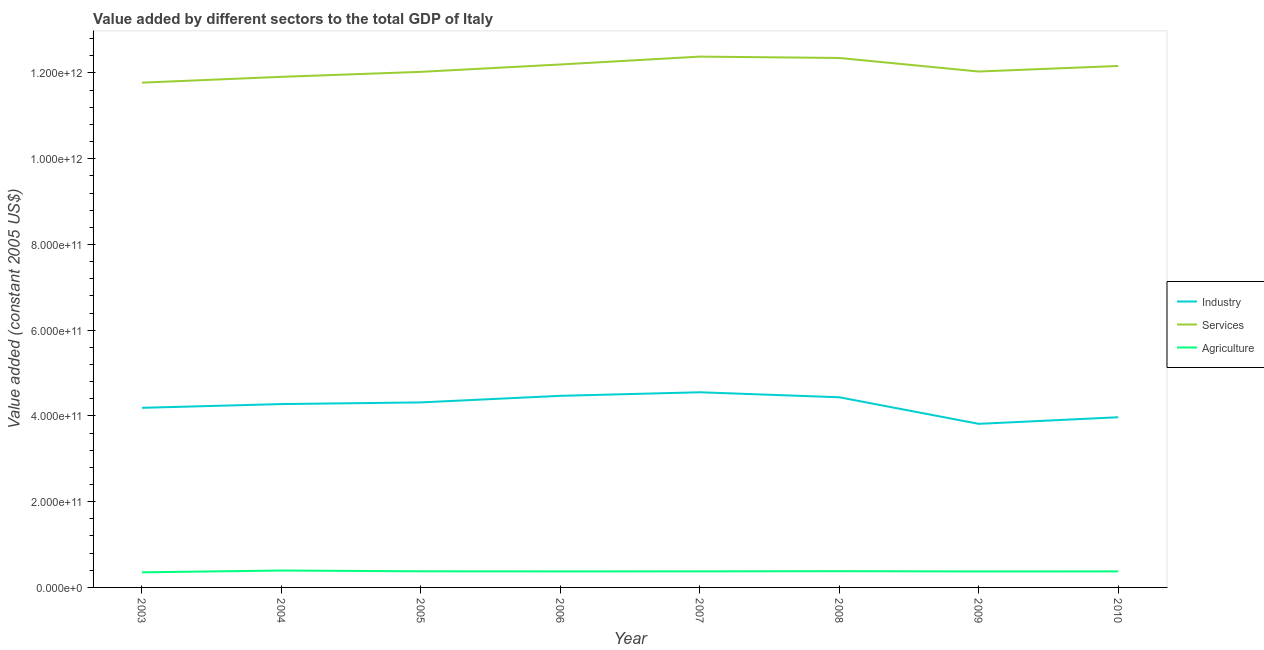What is the value added by industrial sector in 2005?
Provide a short and direct response. 4.32e+11. Across all years, what is the maximum value added by industrial sector?
Make the answer very short. 4.55e+11. Across all years, what is the minimum value added by services?
Offer a terse response. 1.18e+12. What is the total value added by services in the graph?
Your answer should be compact. 9.68e+12. What is the difference between the value added by industrial sector in 2004 and that in 2009?
Offer a terse response. 4.61e+1. What is the difference between the value added by agricultural sector in 2010 and the value added by industrial sector in 2007?
Offer a very short reply. -4.18e+11. What is the average value added by industrial sector per year?
Make the answer very short. 4.25e+11. In the year 2008, what is the difference between the value added by services and value added by industrial sector?
Provide a short and direct response. 7.91e+11. In how many years, is the value added by industrial sector greater than 40000000000 US$?
Offer a very short reply. 8. What is the ratio of the value added by services in 2003 to that in 2010?
Provide a short and direct response. 0.97. Is the value added by services in 2005 less than that in 2009?
Your answer should be compact. Yes. Is the difference between the value added by agricultural sector in 2004 and 2010 greater than the difference between the value added by industrial sector in 2004 and 2010?
Your response must be concise. No. What is the difference between the highest and the second highest value added by industrial sector?
Your answer should be very brief. 8.29e+09. What is the difference between the highest and the lowest value added by industrial sector?
Offer a very short reply. 7.36e+1. Is the value added by industrial sector strictly less than the value added by services over the years?
Provide a short and direct response. Yes. How many years are there in the graph?
Provide a short and direct response. 8. What is the difference between two consecutive major ticks on the Y-axis?
Give a very brief answer. 2.00e+11. Are the values on the major ticks of Y-axis written in scientific E-notation?
Offer a very short reply. Yes. Does the graph contain any zero values?
Your answer should be compact. No. How many legend labels are there?
Make the answer very short. 3. How are the legend labels stacked?
Your response must be concise. Vertical. What is the title of the graph?
Your response must be concise. Value added by different sectors to the total GDP of Italy. Does "Labor Tax" appear as one of the legend labels in the graph?
Keep it short and to the point. No. What is the label or title of the Y-axis?
Keep it short and to the point. Value added (constant 2005 US$). What is the Value added (constant 2005 US$) of Industry in 2003?
Give a very brief answer. 4.19e+11. What is the Value added (constant 2005 US$) of Services in 2003?
Your answer should be compact. 1.18e+12. What is the Value added (constant 2005 US$) of Agriculture in 2003?
Make the answer very short. 3.52e+1. What is the Value added (constant 2005 US$) of Industry in 2004?
Offer a terse response. 4.28e+11. What is the Value added (constant 2005 US$) in Services in 2004?
Your answer should be very brief. 1.19e+12. What is the Value added (constant 2005 US$) in Agriculture in 2004?
Provide a short and direct response. 3.94e+1. What is the Value added (constant 2005 US$) of Industry in 2005?
Offer a very short reply. 4.32e+11. What is the Value added (constant 2005 US$) of Services in 2005?
Provide a short and direct response. 1.20e+12. What is the Value added (constant 2005 US$) of Agriculture in 2005?
Give a very brief answer. 3.76e+1. What is the Value added (constant 2005 US$) in Industry in 2006?
Your answer should be compact. 4.47e+11. What is the Value added (constant 2005 US$) of Services in 2006?
Your answer should be very brief. 1.22e+12. What is the Value added (constant 2005 US$) in Agriculture in 2006?
Make the answer very short. 3.74e+1. What is the Value added (constant 2005 US$) of Industry in 2007?
Provide a short and direct response. 4.55e+11. What is the Value added (constant 2005 US$) in Services in 2007?
Offer a terse response. 1.24e+12. What is the Value added (constant 2005 US$) of Agriculture in 2007?
Your answer should be compact. 3.74e+1. What is the Value added (constant 2005 US$) in Industry in 2008?
Keep it short and to the point. 4.44e+11. What is the Value added (constant 2005 US$) of Services in 2008?
Offer a very short reply. 1.24e+12. What is the Value added (constant 2005 US$) of Agriculture in 2008?
Your answer should be compact. 3.79e+1. What is the Value added (constant 2005 US$) in Industry in 2009?
Ensure brevity in your answer.  3.82e+11. What is the Value added (constant 2005 US$) of Services in 2009?
Make the answer very short. 1.20e+12. What is the Value added (constant 2005 US$) in Agriculture in 2009?
Provide a succinct answer. 3.72e+1. What is the Value added (constant 2005 US$) of Industry in 2010?
Your answer should be compact. 3.97e+11. What is the Value added (constant 2005 US$) of Services in 2010?
Offer a terse response. 1.22e+12. What is the Value added (constant 2005 US$) in Agriculture in 2010?
Your answer should be very brief. 3.74e+1. Across all years, what is the maximum Value added (constant 2005 US$) of Industry?
Keep it short and to the point. 4.55e+11. Across all years, what is the maximum Value added (constant 2005 US$) in Services?
Your response must be concise. 1.24e+12. Across all years, what is the maximum Value added (constant 2005 US$) of Agriculture?
Your response must be concise. 3.94e+1. Across all years, what is the minimum Value added (constant 2005 US$) in Industry?
Your answer should be compact. 3.82e+11. Across all years, what is the minimum Value added (constant 2005 US$) in Services?
Keep it short and to the point. 1.18e+12. Across all years, what is the minimum Value added (constant 2005 US$) in Agriculture?
Give a very brief answer. 3.52e+1. What is the total Value added (constant 2005 US$) of Industry in the graph?
Keep it short and to the point. 3.40e+12. What is the total Value added (constant 2005 US$) of Services in the graph?
Provide a short and direct response. 9.68e+12. What is the total Value added (constant 2005 US$) in Agriculture in the graph?
Your answer should be very brief. 3.00e+11. What is the difference between the Value added (constant 2005 US$) of Industry in 2003 and that in 2004?
Your answer should be compact. -8.75e+09. What is the difference between the Value added (constant 2005 US$) of Services in 2003 and that in 2004?
Make the answer very short. -1.36e+1. What is the difference between the Value added (constant 2005 US$) in Agriculture in 2003 and that in 2004?
Make the answer very short. -4.22e+09. What is the difference between the Value added (constant 2005 US$) in Industry in 2003 and that in 2005?
Ensure brevity in your answer.  -1.27e+1. What is the difference between the Value added (constant 2005 US$) in Services in 2003 and that in 2005?
Offer a terse response. -2.52e+1. What is the difference between the Value added (constant 2005 US$) in Agriculture in 2003 and that in 2005?
Keep it short and to the point. -2.38e+09. What is the difference between the Value added (constant 2005 US$) of Industry in 2003 and that in 2006?
Provide a succinct answer. -2.80e+1. What is the difference between the Value added (constant 2005 US$) of Services in 2003 and that in 2006?
Keep it short and to the point. -4.24e+1. What is the difference between the Value added (constant 2005 US$) of Agriculture in 2003 and that in 2006?
Offer a terse response. -2.15e+09. What is the difference between the Value added (constant 2005 US$) of Industry in 2003 and that in 2007?
Your answer should be very brief. -3.63e+1. What is the difference between the Value added (constant 2005 US$) of Services in 2003 and that in 2007?
Your response must be concise. -6.07e+1. What is the difference between the Value added (constant 2005 US$) in Agriculture in 2003 and that in 2007?
Give a very brief answer. -2.22e+09. What is the difference between the Value added (constant 2005 US$) of Industry in 2003 and that in 2008?
Provide a short and direct response. -2.46e+1. What is the difference between the Value added (constant 2005 US$) of Services in 2003 and that in 2008?
Provide a short and direct response. -5.76e+1. What is the difference between the Value added (constant 2005 US$) of Agriculture in 2003 and that in 2008?
Your answer should be very brief. -2.65e+09. What is the difference between the Value added (constant 2005 US$) of Industry in 2003 and that in 2009?
Provide a short and direct response. 3.74e+1. What is the difference between the Value added (constant 2005 US$) of Services in 2003 and that in 2009?
Offer a very short reply. -2.60e+1. What is the difference between the Value added (constant 2005 US$) in Agriculture in 2003 and that in 2009?
Ensure brevity in your answer.  -2.03e+09. What is the difference between the Value added (constant 2005 US$) of Industry in 2003 and that in 2010?
Make the answer very short. 2.20e+1. What is the difference between the Value added (constant 2005 US$) in Services in 2003 and that in 2010?
Offer a terse response. -3.89e+1. What is the difference between the Value added (constant 2005 US$) of Agriculture in 2003 and that in 2010?
Keep it short and to the point. -2.17e+09. What is the difference between the Value added (constant 2005 US$) in Industry in 2004 and that in 2005?
Offer a very short reply. -3.91e+09. What is the difference between the Value added (constant 2005 US$) in Services in 2004 and that in 2005?
Your answer should be compact. -1.16e+1. What is the difference between the Value added (constant 2005 US$) in Agriculture in 2004 and that in 2005?
Provide a short and direct response. 1.84e+09. What is the difference between the Value added (constant 2005 US$) in Industry in 2004 and that in 2006?
Ensure brevity in your answer.  -1.92e+1. What is the difference between the Value added (constant 2005 US$) in Services in 2004 and that in 2006?
Make the answer very short. -2.88e+1. What is the difference between the Value added (constant 2005 US$) of Agriculture in 2004 and that in 2006?
Keep it short and to the point. 2.06e+09. What is the difference between the Value added (constant 2005 US$) in Industry in 2004 and that in 2007?
Provide a succinct answer. -2.75e+1. What is the difference between the Value added (constant 2005 US$) in Services in 2004 and that in 2007?
Offer a terse response. -4.71e+1. What is the difference between the Value added (constant 2005 US$) of Agriculture in 2004 and that in 2007?
Provide a succinct answer. 2.00e+09. What is the difference between the Value added (constant 2005 US$) of Industry in 2004 and that in 2008?
Your answer should be compact. -1.59e+1. What is the difference between the Value added (constant 2005 US$) in Services in 2004 and that in 2008?
Offer a very short reply. -4.40e+1. What is the difference between the Value added (constant 2005 US$) of Agriculture in 2004 and that in 2008?
Provide a short and direct response. 1.57e+09. What is the difference between the Value added (constant 2005 US$) in Industry in 2004 and that in 2009?
Provide a succinct answer. 4.61e+1. What is the difference between the Value added (constant 2005 US$) in Services in 2004 and that in 2009?
Your answer should be compact. -1.24e+1. What is the difference between the Value added (constant 2005 US$) of Agriculture in 2004 and that in 2009?
Ensure brevity in your answer.  2.18e+09. What is the difference between the Value added (constant 2005 US$) in Industry in 2004 and that in 2010?
Your answer should be compact. 3.07e+1. What is the difference between the Value added (constant 2005 US$) of Services in 2004 and that in 2010?
Offer a very short reply. -2.53e+1. What is the difference between the Value added (constant 2005 US$) in Agriculture in 2004 and that in 2010?
Your answer should be compact. 2.05e+09. What is the difference between the Value added (constant 2005 US$) in Industry in 2005 and that in 2006?
Ensure brevity in your answer.  -1.53e+1. What is the difference between the Value added (constant 2005 US$) in Services in 2005 and that in 2006?
Your answer should be compact. -1.72e+1. What is the difference between the Value added (constant 2005 US$) in Agriculture in 2005 and that in 2006?
Your response must be concise. 2.22e+08. What is the difference between the Value added (constant 2005 US$) in Industry in 2005 and that in 2007?
Your answer should be very brief. -2.36e+1. What is the difference between the Value added (constant 2005 US$) of Services in 2005 and that in 2007?
Your answer should be compact. -3.55e+1. What is the difference between the Value added (constant 2005 US$) of Agriculture in 2005 and that in 2007?
Provide a short and direct response. 1.60e+08. What is the difference between the Value added (constant 2005 US$) of Industry in 2005 and that in 2008?
Provide a succinct answer. -1.20e+1. What is the difference between the Value added (constant 2005 US$) of Services in 2005 and that in 2008?
Your answer should be very brief. -3.24e+1. What is the difference between the Value added (constant 2005 US$) in Agriculture in 2005 and that in 2008?
Ensure brevity in your answer.  -2.73e+08. What is the difference between the Value added (constant 2005 US$) in Industry in 2005 and that in 2009?
Keep it short and to the point. 5.00e+1. What is the difference between the Value added (constant 2005 US$) of Services in 2005 and that in 2009?
Your response must be concise. -7.75e+08. What is the difference between the Value added (constant 2005 US$) in Agriculture in 2005 and that in 2009?
Keep it short and to the point. 3.42e+08. What is the difference between the Value added (constant 2005 US$) of Industry in 2005 and that in 2010?
Offer a terse response. 3.46e+1. What is the difference between the Value added (constant 2005 US$) in Services in 2005 and that in 2010?
Your answer should be very brief. -1.37e+1. What is the difference between the Value added (constant 2005 US$) in Agriculture in 2005 and that in 2010?
Offer a terse response. 2.07e+08. What is the difference between the Value added (constant 2005 US$) of Industry in 2006 and that in 2007?
Your answer should be very brief. -8.29e+09. What is the difference between the Value added (constant 2005 US$) in Services in 2006 and that in 2007?
Give a very brief answer. -1.84e+1. What is the difference between the Value added (constant 2005 US$) of Agriculture in 2006 and that in 2007?
Provide a succinct answer. -6.16e+07. What is the difference between the Value added (constant 2005 US$) in Industry in 2006 and that in 2008?
Provide a succinct answer. 3.36e+09. What is the difference between the Value added (constant 2005 US$) in Services in 2006 and that in 2008?
Provide a short and direct response. -1.52e+1. What is the difference between the Value added (constant 2005 US$) of Agriculture in 2006 and that in 2008?
Your answer should be compact. -4.95e+08. What is the difference between the Value added (constant 2005 US$) in Industry in 2006 and that in 2009?
Make the answer very short. 6.54e+1. What is the difference between the Value added (constant 2005 US$) in Services in 2006 and that in 2009?
Offer a very short reply. 1.64e+1. What is the difference between the Value added (constant 2005 US$) in Agriculture in 2006 and that in 2009?
Your answer should be compact. 1.21e+08. What is the difference between the Value added (constant 2005 US$) of Industry in 2006 and that in 2010?
Your answer should be compact. 5.00e+1. What is the difference between the Value added (constant 2005 US$) of Services in 2006 and that in 2010?
Keep it short and to the point. 3.45e+09. What is the difference between the Value added (constant 2005 US$) in Agriculture in 2006 and that in 2010?
Your answer should be compact. -1.46e+07. What is the difference between the Value added (constant 2005 US$) of Industry in 2007 and that in 2008?
Your response must be concise. 1.17e+1. What is the difference between the Value added (constant 2005 US$) of Services in 2007 and that in 2008?
Your answer should be compact. 3.16e+09. What is the difference between the Value added (constant 2005 US$) of Agriculture in 2007 and that in 2008?
Make the answer very short. -4.34e+08. What is the difference between the Value added (constant 2005 US$) in Industry in 2007 and that in 2009?
Provide a succinct answer. 7.36e+1. What is the difference between the Value added (constant 2005 US$) in Services in 2007 and that in 2009?
Keep it short and to the point. 3.48e+1. What is the difference between the Value added (constant 2005 US$) in Agriculture in 2007 and that in 2009?
Your answer should be compact. 1.82e+08. What is the difference between the Value added (constant 2005 US$) of Industry in 2007 and that in 2010?
Offer a terse response. 5.83e+1. What is the difference between the Value added (constant 2005 US$) in Services in 2007 and that in 2010?
Your response must be concise. 2.18e+1. What is the difference between the Value added (constant 2005 US$) of Agriculture in 2007 and that in 2010?
Your response must be concise. 4.69e+07. What is the difference between the Value added (constant 2005 US$) of Industry in 2008 and that in 2009?
Keep it short and to the point. 6.20e+1. What is the difference between the Value added (constant 2005 US$) of Services in 2008 and that in 2009?
Offer a terse response. 3.16e+1. What is the difference between the Value added (constant 2005 US$) of Agriculture in 2008 and that in 2009?
Keep it short and to the point. 6.16e+08. What is the difference between the Value added (constant 2005 US$) in Industry in 2008 and that in 2010?
Offer a terse response. 4.66e+1. What is the difference between the Value added (constant 2005 US$) in Services in 2008 and that in 2010?
Give a very brief answer. 1.87e+1. What is the difference between the Value added (constant 2005 US$) in Agriculture in 2008 and that in 2010?
Provide a succinct answer. 4.81e+08. What is the difference between the Value added (constant 2005 US$) in Industry in 2009 and that in 2010?
Your response must be concise. -1.54e+1. What is the difference between the Value added (constant 2005 US$) of Services in 2009 and that in 2010?
Your answer should be very brief. -1.30e+1. What is the difference between the Value added (constant 2005 US$) in Agriculture in 2009 and that in 2010?
Provide a short and direct response. -1.35e+08. What is the difference between the Value added (constant 2005 US$) in Industry in 2003 and the Value added (constant 2005 US$) in Services in 2004?
Your response must be concise. -7.72e+11. What is the difference between the Value added (constant 2005 US$) in Industry in 2003 and the Value added (constant 2005 US$) in Agriculture in 2004?
Your answer should be compact. 3.80e+11. What is the difference between the Value added (constant 2005 US$) in Services in 2003 and the Value added (constant 2005 US$) in Agriculture in 2004?
Your response must be concise. 1.14e+12. What is the difference between the Value added (constant 2005 US$) in Industry in 2003 and the Value added (constant 2005 US$) in Services in 2005?
Offer a terse response. -7.84e+11. What is the difference between the Value added (constant 2005 US$) of Industry in 2003 and the Value added (constant 2005 US$) of Agriculture in 2005?
Make the answer very short. 3.81e+11. What is the difference between the Value added (constant 2005 US$) in Services in 2003 and the Value added (constant 2005 US$) in Agriculture in 2005?
Your answer should be very brief. 1.14e+12. What is the difference between the Value added (constant 2005 US$) in Industry in 2003 and the Value added (constant 2005 US$) in Services in 2006?
Your answer should be compact. -8.01e+11. What is the difference between the Value added (constant 2005 US$) of Industry in 2003 and the Value added (constant 2005 US$) of Agriculture in 2006?
Offer a very short reply. 3.82e+11. What is the difference between the Value added (constant 2005 US$) of Services in 2003 and the Value added (constant 2005 US$) of Agriculture in 2006?
Give a very brief answer. 1.14e+12. What is the difference between the Value added (constant 2005 US$) in Industry in 2003 and the Value added (constant 2005 US$) in Services in 2007?
Offer a very short reply. -8.19e+11. What is the difference between the Value added (constant 2005 US$) of Industry in 2003 and the Value added (constant 2005 US$) of Agriculture in 2007?
Offer a very short reply. 3.82e+11. What is the difference between the Value added (constant 2005 US$) of Services in 2003 and the Value added (constant 2005 US$) of Agriculture in 2007?
Keep it short and to the point. 1.14e+12. What is the difference between the Value added (constant 2005 US$) in Industry in 2003 and the Value added (constant 2005 US$) in Services in 2008?
Provide a short and direct response. -8.16e+11. What is the difference between the Value added (constant 2005 US$) of Industry in 2003 and the Value added (constant 2005 US$) of Agriculture in 2008?
Make the answer very short. 3.81e+11. What is the difference between the Value added (constant 2005 US$) in Services in 2003 and the Value added (constant 2005 US$) in Agriculture in 2008?
Give a very brief answer. 1.14e+12. What is the difference between the Value added (constant 2005 US$) of Industry in 2003 and the Value added (constant 2005 US$) of Services in 2009?
Give a very brief answer. -7.84e+11. What is the difference between the Value added (constant 2005 US$) in Industry in 2003 and the Value added (constant 2005 US$) in Agriculture in 2009?
Give a very brief answer. 3.82e+11. What is the difference between the Value added (constant 2005 US$) of Services in 2003 and the Value added (constant 2005 US$) of Agriculture in 2009?
Provide a succinct answer. 1.14e+12. What is the difference between the Value added (constant 2005 US$) in Industry in 2003 and the Value added (constant 2005 US$) in Services in 2010?
Offer a very short reply. -7.97e+11. What is the difference between the Value added (constant 2005 US$) in Industry in 2003 and the Value added (constant 2005 US$) in Agriculture in 2010?
Provide a short and direct response. 3.82e+11. What is the difference between the Value added (constant 2005 US$) of Services in 2003 and the Value added (constant 2005 US$) of Agriculture in 2010?
Offer a very short reply. 1.14e+12. What is the difference between the Value added (constant 2005 US$) in Industry in 2004 and the Value added (constant 2005 US$) in Services in 2005?
Offer a very short reply. -7.75e+11. What is the difference between the Value added (constant 2005 US$) in Industry in 2004 and the Value added (constant 2005 US$) in Agriculture in 2005?
Keep it short and to the point. 3.90e+11. What is the difference between the Value added (constant 2005 US$) of Services in 2004 and the Value added (constant 2005 US$) of Agriculture in 2005?
Offer a terse response. 1.15e+12. What is the difference between the Value added (constant 2005 US$) in Industry in 2004 and the Value added (constant 2005 US$) in Services in 2006?
Give a very brief answer. -7.92e+11. What is the difference between the Value added (constant 2005 US$) of Industry in 2004 and the Value added (constant 2005 US$) of Agriculture in 2006?
Provide a short and direct response. 3.90e+11. What is the difference between the Value added (constant 2005 US$) of Services in 2004 and the Value added (constant 2005 US$) of Agriculture in 2006?
Your response must be concise. 1.15e+12. What is the difference between the Value added (constant 2005 US$) in Industry in 2004 and the Value added (constant 2005 US$) in Services in 2007?
Give a very brief answer. -8.10e+11. What is the difference between the Value added (constant 2005 US$) of Industry in 2004 and the Value added (constant 2005 US$) of Agriculture in 2007?
Give a very brief answer. 3.90e+11. What is the difference between the Value added (constant 2005 US$) of Services in 2004 and the Value added (constant 2005 US$) of Agriculture in 2007?
Your answer should be very brief. 1.15e+12. What is the difference between the Value added (constant 2005 US$) in Industry in 2004 and the Value added (constant 2005 US$) in Services in 2008?
Provide a succinct answer. -8.07e+11. What is the difference between the Value added (constant 2005 US$) in Industry in 2004 and the Value added (constant 2005 US$) in Agriculture in 2008?
Provide a succinct answer. 3.90e+11. What is the difference between the Value added (constant 2005 US$) in Services in 2004 and the Value added (constant 2005 US$) in Agriculture in 2008?
Offer a terse response. 1.15e+12. What is the difference between the Value added (constant 2005 US$) in Industry in 2004 and the Value added (constant 2005 US$) in Services in 2009?
Your response must be concise. -7.76e+11. What is the difference between the Value added (constant 2005 US$) in Industry in 2004 and the Value added (constant 2005 US$) in Agriculture in 2009?
Provide a succinct answer. 3.90e+11. What is the difference between the Value added (constant 2005 US$) of Services in 2004 and the Value added (constant 2005 US$) of Agriculture in 2009?
Keep it short and to the point. 1.15e+12. What is the difference between the Value added (constant 2005 US$) of Industry in 2004 and the Value added (constant 2005 US$) of Services in 2010?
Ensure brevity in your answer.  -7.89e+11. What is the difference between the Value added (constant 2005 US$) of Industry in 2004 and the Value added (constant 2005 US$) of Agriculture in 2010?
Offer a terse response. 3.90e+11. What is the difference between the Value added (constant 2005 US$) in Services in 2004 and the Value added (constant 2005 US$) in Agriculture in 2010?
Provide a short and direct response. 1.15e+12. What is the difference between the Value added (constant 2005 US$) in Industry in 2005 and the Value added (constant 2005 US$) in Services in 2006?
Make the answer very short. -7.88e+11. What is the difference between the Value added (constant 2005 US$) in Industry in 2005 and the Value added (constant 2005 US$) in Agriculture in 2006?
Keep it short and to the point. 3.94e+11. What is the difference between the Value added (constant 2005 US$) of Services in 2005 and the Value added (constant 2005 US$) of Agriculture in 2006?
Provide a succinct answer. 1.17e+12. What is the difference between the Value added (constant 2005 US$) of Industry in 2005 and the Value added (constant 2005 US$) of Services in 2007?
Provide a short and direct response. -8.07e+11. What is the difference between the Value added (constant 2005 US$) in Industry in 2005 and the Value added (constant 2005 US$) in Agriculture in 2007?
Your response must be concise. 3.94e+11. What is the difference between the Value added (constant 2005 US$) of Services in 2005 and the Value added (constant 2005 US$) of Agriculture in 2007?
Your response must be concise. 1.17e+12. What is the difference between the Value added (constant 2005 US$) of Industry in 2005 and the Value added (constant 2005 US$) of Services in 2008?
Provide a short and direct response. -8.03e+11. What is the difference between the Value added (constant 2005 US$) of Industry in 2005 and the Value added (constant 2005 US$) of Agriculture in 2008?
Keep it short and to the point. 3.94e+11. What is the difference between the Value added (constant 2005 US$) in Services in 2005 and the Value added (constant 2005 US$) in Agriculture in 2008?
Your response must be concise. 1.16e+12. What is the difference between the Value added (constant 2005 US$) of Industry in 2005 and the Value added (constant 2005 US$) of Services in 2009?
Offer a very short reply. -7.72e+11. What is the difference between the Value added (constant 2005 US$) of Industry in 2005 and the Value added (constant 2005 US$) of Agriculture in 2009?
Ensure brevity in your answer.  3.94e+11. What is the difference between the Value added (constant 2005 US$) in Services in 2005 and the Value added (constant 2005 US$) in Agriculture in 2009?
Offer a very short reply. 1.17e+12. What is the difference between the Value added (constant 2005 US$) of Industry in 2005 and the Value added (constant 2005 US$) of Services in 2010?
Make the answer very short. -7.85e+11. What is the difference between the Value added (constant 2005 US$) of Industry in 2005 and the Value added (constant 2005 US$) of Agriculture in 2010?
Ensure brevity in your answer.  3.94e+11. What is the difference between the Value added (constant 2005 US$) in Services in 2005 and the Value added (constant 2005 US$) in Agriculture in 2010?
Offer a terse response. 1.17e+12. What is the difference between the Value added (constant 2005 US$) of Industry in 2006 and the Value added (constant 2005 US$) of Services in 2007?
Your response must be concise. -7.91e+11. What is the difference between the Value added (constant 2005 US$) in Industry in 2006 and the Value added (constant 2005 US$) in Agriculture in 2007?
Ensure brevity in your answer.  4.09e+11. What is the difference between the Value added (constant 2005 US$) of Services in 2006 and the Value added (constant 2005 US$) of Agriculture in 2007?
Make the answer very short. 1.18e+12. What is the difference between the Value added (constant 2005 US$) in Industry in 2006 and the Value added (constant 2005 US$) in Services in 2008?
Give a very brief answer. -7.88e+11. What is the difference between the Value added (constant 2005 US$) in Industry in 2006 and the Value added (constant 2005 US$) in Agriculture in 2008?
Make the answer very short. 4.09e+11. What is the difference between the Value added (constant 2005 US$) in Services in 2006 and the Value added (constant 2005 US$) in Agriculture in 2008?
Your answer should be compact. 1.18e+12. What is the difference between the Value added (constant 2005 US$) of Industry in 2006 and the Value added (constant 2005 US$) of Services in 2009?
Your response must be concise. -7.56e+11. What is the difference between the Value added (constant 2005 US$) in Industry in 2006 and the Value added (constant 2005 US$) in Agriculture in 2009?
Provide a succinct answer. 4.10e+11. What is the difference between the Value added (constant 2005 US$) in Services in 2006 and the Value added (constant 2005 US$) in Agriculture in 2009?
Keep it short and to the point. 1.18e+12. What is the difference between the Value added (constant 2005 US$) in Industry in 2006 and the Value added (constant 2005 US$) in Services in 2010?
Your answer should be compact. -7.69e+11. What is the difference between the Value added (constant 2005 US$) in Industry in 2006 and the Value added (constant 2005 US$) in Agriculture in 2010?
Your answer should be compact. 4.10e+11. What is the difference between the Value added (constant 2005 US$) in Services in 2006 and the Value added (constant 2005 US$) in Agriculture in 2010?
Offer a very short reply. 1.18e+12. What is the difference between the Value added (constant 2005 US$) of Industry in 2007 and the Value added (constant 2005 US$) of Services in 2008?
Give a very brief answer. -7.80e+11. What is the difference between the Value added (constant 2005 US$) in Industry in 2007 and the Value added (constant 2005 US$) in Agriculture in 2008?
Make the answer very short. 4.17e+11. What is the difference between the Value added (constant 2005 US$) in Services in 2007 and the Value added (constant 2005 US$) in Agriculture in 2008?
Your answer should be compact. 1.20e+12. What is the difference between the Value added (constant 2005 US$) in Industry in 2007 and the Value added (constant 2005 US$) in Services in 2009?
Your answer should be compact. -7.48e+11. What is the difference between the Value added (constant 2005 US$) of Industry in 2007 and the Value added (constant 2005 US$) of Agriculture in 2009?
Your answer should be compact. 4.18e+11. What is the difference between the Value added (constant 2005 US$) of Services in 2007 and the Value added (constant 2005 US$) of Agriculture in 2009?
Keep it short and to the point. 1.20e+12. What is the difference between the Value added (constant 2005 US$) in Industry in 2007 and the Value added (constant 2005 US$) in Services in 2010?
Your answer should be very brief. -7.61e+11. What is the difference between the Value added (constant 2005 US$) in Industry in 2007 and the Value added (constant 2005 US$) in Agriculture in 2010?
Offer a terse response. 4.18e+11. What is the difference between the Value added (constant 2005 US$) of Services in 2007 and the Value added (constant 2005 US$) of Agriculture in 2010?
Make the answer very short. 1.20e+12. What is the difference between the Value added (constant 2005 US$) of Industry in 2008 and the Value added (constant 2005 US$) of Services in 2009?
Ensure brevity in your answer.  -7.60e+11. What is the difference between the Value added (constant 2005 US$) of Industry in 2008 and the Value added (constant 2005 US$) of Agriculture in 2009?
Your answer should be compact. 4.06e+11. What is the difference between the Value added (constant 2005 US$) in Services in 2008 and the Value added (constant 2005 US$) in Agriculture in 2009?
Provide a short and direct response. 1.20e+12. What is the difference between the Value added (constant 2005 US$) of Industry in 2008 and the Value added (constant 2005 US$) of Services in 2010?
Provide a succinct answer. -7.73e+11. What is the difference between the Value added (constant 2005 US$) in Industry in 2008 and the Value added (constant 2005 US$) in Agriculture in 2010?
Provide a succinct answer. 4.06e+11. What is the difference between the Value added (constant 2005 US$) of Services in 2008 and the Value added (constant 2005 US$) of Agriculture in 2010?
Your response must be concise. 1.20e+12. What is the difference between the Value added (constant 2005 US$) of Industry in 2009 and the Value added (constant 2005 US$) of Services in 2010?
Your response must be concise. -8.35e+11. What is the difference between the Value added (constant 2005 US$) in Industry in 2009 and the Value added (constant 2005 US$) in Agriculture in 2010?
Keep it short and to the point. 3.44e+11. What is the difference between the Value added (constant 2005 US$) of Services in 2009 and the Value added (constant 2005 US$) of Agriculture in 2010?
Keep it short and to the point. 1.17e+12. What is the average Value added (constant 2005 US$) of Industry per year?
Your answer should be very brief. 4.25e+11. What is the average Value added (constant 2005 US$) in Services per year?
Your answer should be very brief. 1.21e+12. What is the average Value added (constant 2005 US$) in Agriculture per year?
Keep it short and to the point. 3.74e+1. In the year 2003, what is the difference between the Value added (constant 2005 US$) of Industry and Value added (constant 2005 US$) of Services?
Keep it short and to the point. -7.59e+11. In the year 2003, what is the difference between the Value added (constant 2005 US$) of Industry and Value added (constant 2005 US$) of Agriculture?
Offer a very short reply. 3.84e+11. In the year 2003, what is the difference between the Value added (constant 2005 US$) in Services and Value added (constant 2005 US$) in Agriculture?
Make the answer very short. 1.14e+12. In the year 2004, what is the difference between the Value added (constant 2005 US$) of Industry and Value added (constant 2005 US$) of Services?
Make the answer very short. -7.63e+11. In the year 2004, what is the difference between the Value added (constant 2005 US$) in Industry and Value added (constant 2005 US$) in Agriculture?
Offer a terse response. 3.88e+11. In the year 2004, what is the difference between the Value added (constant 2005 US$) of Services and Value added (constant 2005 US$) of Agriculture?
Your answer should be compact. 1.15e+12. In the year 2005, what is the difference between the Value added (constant 2005 US$) of Industry and Value added (constant 2005 US$) of Services?
Keep it short and to the point. -7.71e+11. In the year 2005, what is the difference between the Value added (constant 2005 US$) of Industry and Value added (constant 2005 US$) of Agriculture?
Your response must be concise. 3.94e+11. In the year 2005, what is the difference between the Value added (constant 2005 US$) of Services and Value added (constant 2005 US$) of Agriculture?
Offer a terse response. 1.17e+12. In the year 2006, what is the difference between the Value added (constant 2005 US$) of Industry and Value added (constant 2005 US$) of Services?
Provide a succinct answer. -7.73e+11. In the year 2006, what is the difference between the Value added (constant 2005 US$) of Industry and Value added (constant 2005 US$) of Agriculture?
Ensure brevity in your answer.  4.10e+11. In the year 2006, what is the difference between the Value added (constant 2005 US$) of Services and Value added (constant 2005 US$) of Agriculture?
Your answer should be compact. 1.18e+12. In the year 2007, what is the difference between the Value added (constant 2005 US$) in Industry and Value added (constant 2005 US$) in Services?
Provide a short and direct response. -7.83e+11. In the year 2007, what is the difference between the Value added (constant 2005 US$) of Industry and Value added (constant 2005 US$) of Agriculture?
Your answer should be compact. 4.18e+11. In the year 2007, what is the difference between the Value added (constant 2005 US$) in Services and Value added (constant 2005 US$) in Agriculture?
Offer a very short reply. 1.20e+12. In the year 2008, what is the difference between the Value added (constant 2005 US$) of Industry and Value added (constant 2005 US$) of Services?
Your response must be concise. -7.91e+11. In the year 2008, what is the difference between the Value added (constant 2005 US$) in Industry and Value added (constant 2005 US$) in Agriculture?
Keep it short and to the point. 4.06e+11. In the year 2008, what is the difference between the Value added (constant 2005 US$) in Services and Value added (constant 2005 US$) in Agriculture?
Offer a terse response. 1.20e+12. In the year 2009, what is the difference between the Value added (constant 2005 US$) of Industry and Value added (constant 2005 US$) of Services?
Your response must be concise. -8.22e+11. In the year 2009, what is the difference between the Value added (constant 2005 US$) of Industry and Value added (constant 2005 US$) of Agriculture?
Offer a terse response. 3.44e+11. In the year 2009, what is the difference between the Value added (constant 2005 US$) of Services and Value added (constant 2005 US$) of Agriculture?
Your answer should be compact. 1.17e+12. In the year 2010, what is the difference between the Value added (constant 2005 US$) of Industry and Value added (constant 2005 US$) of Services?
Keep it short and to the point. -8.19e+11. In the year 2010, what is the difference between the Value added (constant 2005 US$) of Industry and Value added (constant 2005 US$) of Agriculture?
Your response must be concise. 3.60e+11. In the year 2010, what is the difference between the Value added (constant 2005 US$) of Services and Value added (constant 2005 US$) of Agriculture?
Offer a very short reply. 1.18e+12. What is the ratio of the Value added (constant 2005 US$) of Industry in 2003 to that in 2004?
Provide a succinct answer. 0.98. What is the ratio of the Value added (constant 2005 US$) of Agriculture in 2003 to that in 2004?
Provide a short and direct response. 0.89. What is the ratio of the Value added (constant 2005 US$) in Industry in 2003 to that in 2005?
Keep it short and to the point. 0.97. What is the ratio of the Value added (constant 2005 US$) of Services in 2003 to that in 2005?
Offer a terse response. 0.98. What is the ratio of the Value added (constant 2005 US$) of Agriculture in 2003 to that in 2005?
Provide a succinct answer. 0.94. What is the ratio of the Value added (constant 2005 US$) of Industry in 2003 to that in 2006?
Your answer should be compact. 0.94. What is the ratio of the Value added (constant 2005 US$) of Services in 2003 to that in 2006?
Make the answer very short. 0.97. What is the ratio of the Value added (constant 2005 US$) of Agriculture in 2003 to that in 2006?
Offer a terse response. 0.94. What is the ratio of the Value added (constant 2005 US$) of Industry in 2003 to that in 2007?
Your answer should be compact. 0.92. What is the ratio of the Value added (constant 2005 US$) in Services in 2003 to that in 2007?
Provide a succinct answer. 0.95. What is the ratio of the Value added (constant 2005 US$) in Agriculture in 2003 to that in 2007?
Provide a short and direct response. 0.94. What is the ratio of the Value added (constant 2005 US$) in Industry in 2003 to that in 2008?
Your answer should be very brief. 0.94. What is the ratio of the Value added (constant 2005 US$) of Services in 2003 to that in 2008?
Offer a very short reply. 0.95. What is the ratio of the Value added (constant 2005 US$) in Agriculture in 2003 to that in 2008?
Make the answer very short. 0.93. What is the ratio of the Value added (constant 2005 US$) of Industry in 2003 to that in 2009?
Offer a terse response. 1.1. What is the ratio of the Value added (constant 2005 US$) of Services in 2003 to that in 2009?
Give a very brief answer. 0.98. What is the ratio of the Value added (constant 2005 US$) in Agriculture in 2003 to that in 2009?
Your answer should be compact. 0.95. What is the ratio of the Value added (constant 2005 US$) in Industry in 2003 to that in 2010?
Ensure brevity in your answer.  1.06. What is the ratio of the Value added (constant 2005 US$) in Services in 2003 to that in 2010?
Offer a terse response. 0.97. What is the ratio of the Value added (constant 2005 US$) in Agriculture in 2003 to that in 2010?
Your answer should be compact. 0.94. What is the ratio of the Value added (constant 2005 US$) of Industry in 2004 to that in 2005?
Offer a terse response. 0.99. What is the ratio of the Value added (constant 2005 US$) of Agriculture in 2004 to that in 2005?
Your answer should be compact. 1.05. What is the ratio of the Value added (constant 2005 US$) of Industry in 2004 to that in 2006?
Ensure brevity in your answer.  0.96. What is the ratio of the Value added (constant 2005 US$) in Services in 2004 to that in 2006?
Give a very brief answer. 0.98. What is the ratio of the Value added (constant 2005 US$) in Agriculture in 2004 to that in 2006?
Give a very brief answer. 1.06. What is the ratio of the Value added (constant 2005 US$) in Industry in 2004 to that in 2007?
Your response must be concise. 0.94. What is the ratio of the Value added (constant 2005 US$) in Services in 2004 to that in 2007?
Your response must be concise. 0.96. What is the ratio of the Value added (constant 2005 US$) in Agriculture in 2004 to that in 2007?
Your response must be concise. 1.05. What is the ratio of the Value added (constant 2005 US$) of Industry in 2004 to that in 2008?
Offer a terse response. 0.96. What is the ratio of the Value added (constant 2005 US$) in Services in 2004 to that in 2008?
Keep it short and to the point. 0.96. What is the ratio of the Value added (constant 2005 US$) in Agriculture in 2004 to that in 2008?
Your answer should be very brief. 1.04. What is the ratio of the Value added (constant 2005 US$) of Industry in 2004 to that in 2009?
Offer a terse response. 1.12. What is the ratio of the Value added (constant 2005 US$) of Agriculture in 2004 to that in 2009?
Ensure brevity in your answer.  1.06. What is the ratio of the Value added (constant 2005 US$) of Industry in 2004 to that in 2010?
Offer a very short reply. 1.08. What is the ratio of the Value added (constant 2005 US$) in Services in 2004 to that in 2010?
Give a very brief answer. 0.98. What is the ratio of the Value added (constant 2005 US$) of Agriculture in 2004 to that in 2010?
Provide a short and direct response. 1.05. What is the ratio of the Value added (constant 2005 US$) in Industry in 2005 to that in 2006?
Make the answer very short. 0.97. What is the ratio of the Value added (constant 2005 US$) in Services in 2005 to that in 2006?
Give a very brief answer. 0.99. What is the ratio of the Value added (constant 2005 US$) in Agriculture in 2005 to that in 2006?
Provide a succinct answer. 1.01. What is the ratio of the Value added (constant 2005 US$) of Industry in 2005 to that in 2007?
Your answer should be very brief. 0.95. What is the ratio of the Value added (constant 2005 US$) in Services in 2005 to that in 2007?
Give a very brief answer. 0.97. What is the ratio of the Value added (constant 2005 US$) in Industry in 2005 to that in 2008?
Offer a very short reply. 0.97. What is the ratio of the Value added (constant 2005 US$) of Services in 2005 to that in 2008?
Your answer should be compact. 0.97. What is the ratio of the Value added (constant 2005 US$) of Industry in 2005 to that in 2009?
Ensure brevity in your answer.  1.13. What is the ratio of the Value added (constant 2005 US$) of Services in 2005 to that in 2009?
Ensure brevity in your answer.  1. What is the ratio of the Value added (constant 2005 US$) in Agriculture in 2005 to that in 2009?
Your answer should be very brief. 1.01. What is the ratio of the Value added (constant 2005 US$) in Industry in 2005 to that in 2010?
Your response must be concise. 1.09. What is the ratio of the Value added (constant 2005 US$) of Services in 2005 to that in 2010?
Your response must be concise. 0.99. What is the ratio of the Value added (constant 2005 US$) of Agriculture in 2005 to that in 2010?
Give a very brief answer. 1.01. What is the ratio of the Value added (constant 2005 US$) in Industry in 2006 to that in 2007?
Make the answer very short. 0.98. What is the ratio of the Value added (constant 2005 US$) in Services in 2006 to that in 2007?
Give a very brief answer. 0.99. What is the ratio of the Value added (constant 2005 US$) in Agriculture in 2006 to that in 2007?
Offer a terse response. 1. What is the ratio of the Value added (constant 2005 US$) of Industry in 2006 to that in 2008?
Provide a succinct answer. 1.01. What is the ratio of the Value added (constant 2005 US$) of Services in 2006 to that in 2008?
Provide a succinct answer. 0.99. What is the ratio of the Value added (constant 2005 US$) of Agriculture in 2006 to that in 2008?
Keep it short and to the point. 0.99. What is the ratio of the Value added (constant 2005 US$) in Industry in 2006 to that in 2009?
Provide a succinct answer. 1.17. What is the ratio of the Value added (constant 2005 US$) in Services in 2006 to that in 2009?
Offer a very short reply. 1.01. What is the ratio of the Value added (constant 2005 US$) in Agriculture in 2006 to that in 2009?
Your answer should be compact. 1. What is the ratio of the Value added (constant 2005 US$) of Industry in 2006 to that in 2010?
Ensure brevity in your answer.  1.13. What is the ratio of the Value added (constant 2005 US$) of Industry in 2007 to that in 2008?
Your answer should be very brief. 1.03. What is the ratio of the Value added (constant 2005 US$) of Services in 2007 to that in 2008?
Provide a succinct answer. 1. What is the ratio of the Value added (constant 2005 US$) in Industry in 2007 to that in 2009?
Provide a succinct answer. 1.19. What is the ratio of the Value added (constant 2005 US$) of Services in 2007 to that in 2009?
Offer a very short reply. 1.03. What is the ratio of the Value added (constant 2005 US$) in Industry in 2007 to that in 2010?
Keep it short and to the point. 1.15. What is the ratio of the Value added (constant 2005 US$) in Services in 2007 to that in 2010?
Provide a short and direct response. 1.02. What is the ratio of the Value added (constant 2005 US$) of Agriculture in 2007 to that in 2010?
Your answer should be very brief. 1. What is the ratio of the Value added (constant 2005 US$) of Industry in 2008 to that in 2009?
Your answer should be very brief. 1.16. What is the ratio of the Value added (constant 2005 US$) in Services in 2008 to that in 2009?
Keep it short and to the point. 1.03. What is the ratio of the Value added (constant 2005 US$) in Agriculture in 2008 to that in 2009?
Your response must be concise. 1.02. What is the ratio of the Value added (constant 2005 US$) in Industry in 2008 to that in 2010?
Offer a very short reply. 1.12. What is the ratio of the Value added (constant 2005 US$) of Services in 2008 to that in 2010?
Offer a very short reply. 1.02. What is the ratio of the Value added (constant 2005 US$) in Agriculture in 2008 to that in 2010?
Your answer should be compact. 1.01. What is the ratio of the Value added (constant 2005 US$) in Industry in 2009 to that in 2010?
Offer a very short reply. 0.96. What is the ratio of the Value added (constant 2005 US$) of Services in 2009 to that in 2010?
Provide a short and direct response. 0.99. What is the ratio of the Value added (constant 2005 US$) of Agriculture in 2009 to that in 2010?
Your answer should be very brief. 1. What is the difference between the highest and the second highest Value added (constant 2005 US$) of Industry?
Your answer should be very brief. 8.29e+09. What is the difference between the highest and the second highest Value added (constant 2005 US$) of Services?
Provide a succinct answer. 3.16e+09. What is the difference between the highest and the second highest Value added (constant 2005 US$) of Agriculture?
Your response must be concise. 1.57e+09. What is the difference between the highest and the lowest Value added (constant 2005 US$) in Industry?
Ensure brevity in your answer.  7.36e+1. What is the difference between the highest and the lowest Value added (constant 2005 US$) of Services?
Provide a succinct answer. 6.07e+1. What is the difference between the highest and the lowest Value added (constant 2005 US$) in Agriculture?
Ensure brevity in your answer.  4.22e+09. 